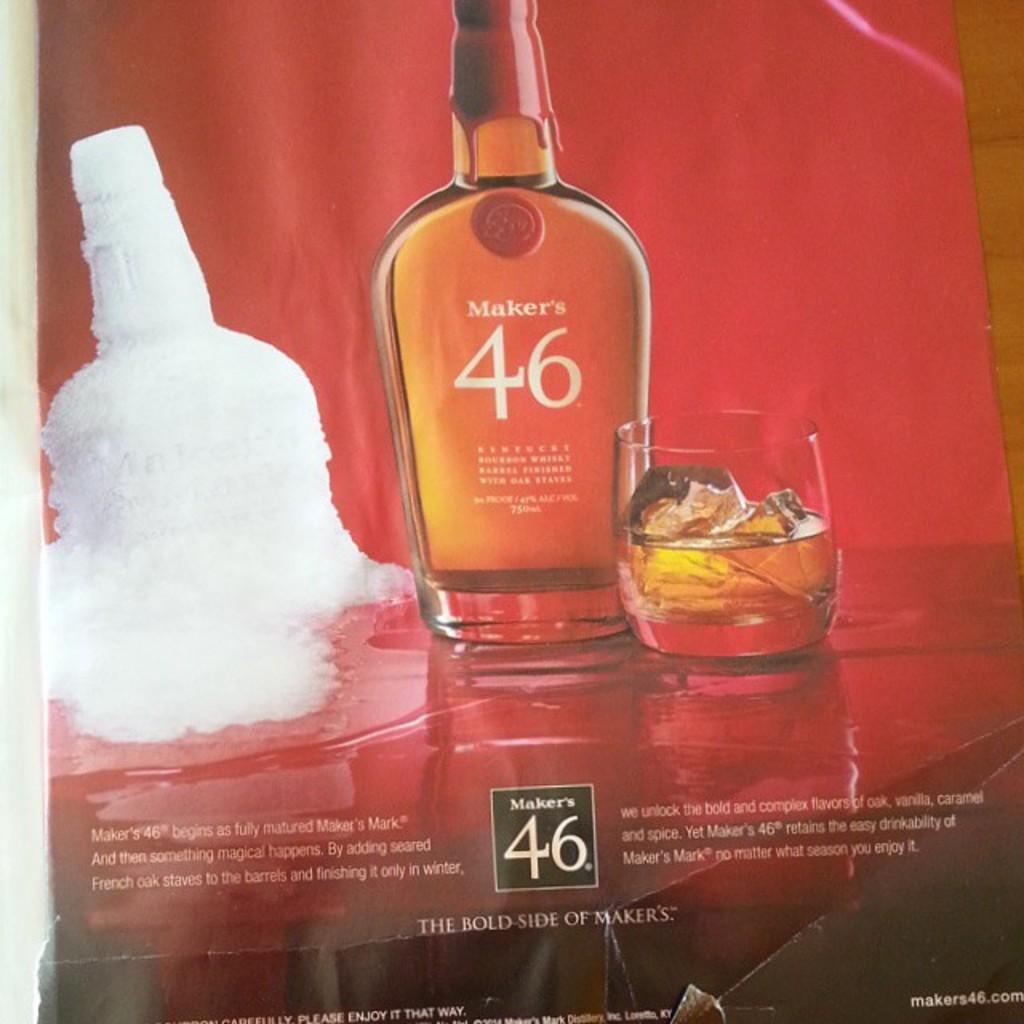What is the main object in the image? There is a bottle present in the image. What else can be seen in the image related to the bottle? A glass with a drink is visible in the image. How is the bottle being kept cool? The bottle is covered with ice. What type of sack is being used to transport the boat in the image? There is no sack or boat present in the image; it only features a bottle and a glass with a drink. What role does the war play in the image? There is no mention of war or any conflict in the image; it is focused on a bottle and a glass with a drink. 